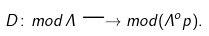<formula> <loc_0><loc_0><loc_500><loc_500>D \colon m o d \, \Lambda \longrightarrow m o d ( \Lambda ^ { o } p ) .</formula> 